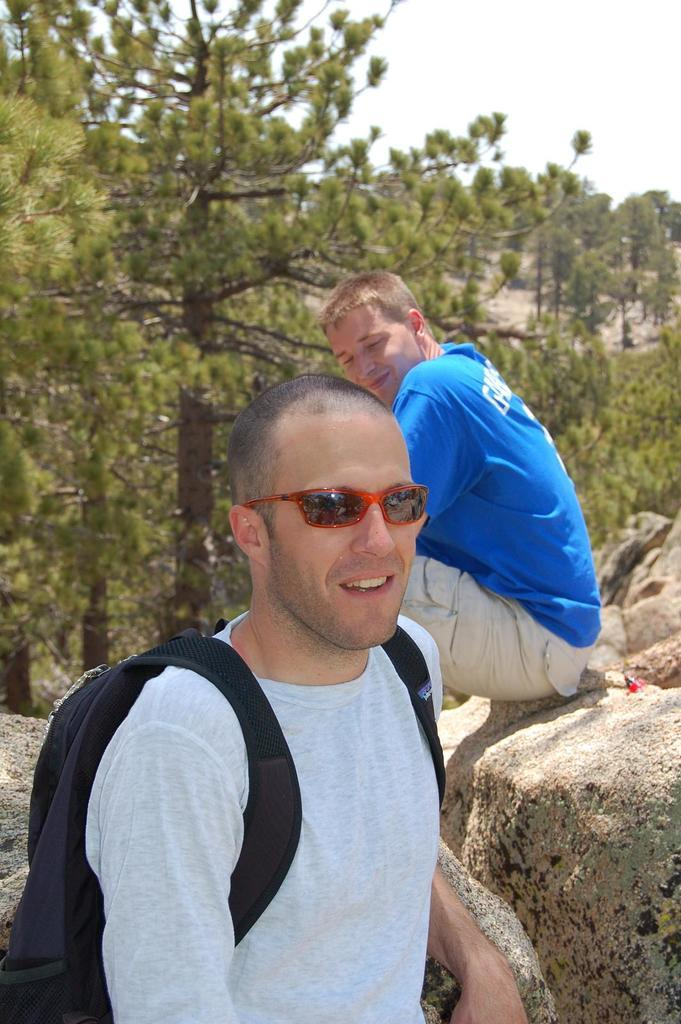What is the position of the first man in the image? There is a man standing on the ground in the image. What is the position of the second man in the image? There is a man sitting on the rocks in the image. What can be seen in the background of the image? There are trees and the sky visible in the background of the image. What type of drum can be seen in the image? There is no drum present in the image. How many fingers does the man standing on the ground have? The number of fingers the man has cannot be determined from the image. 